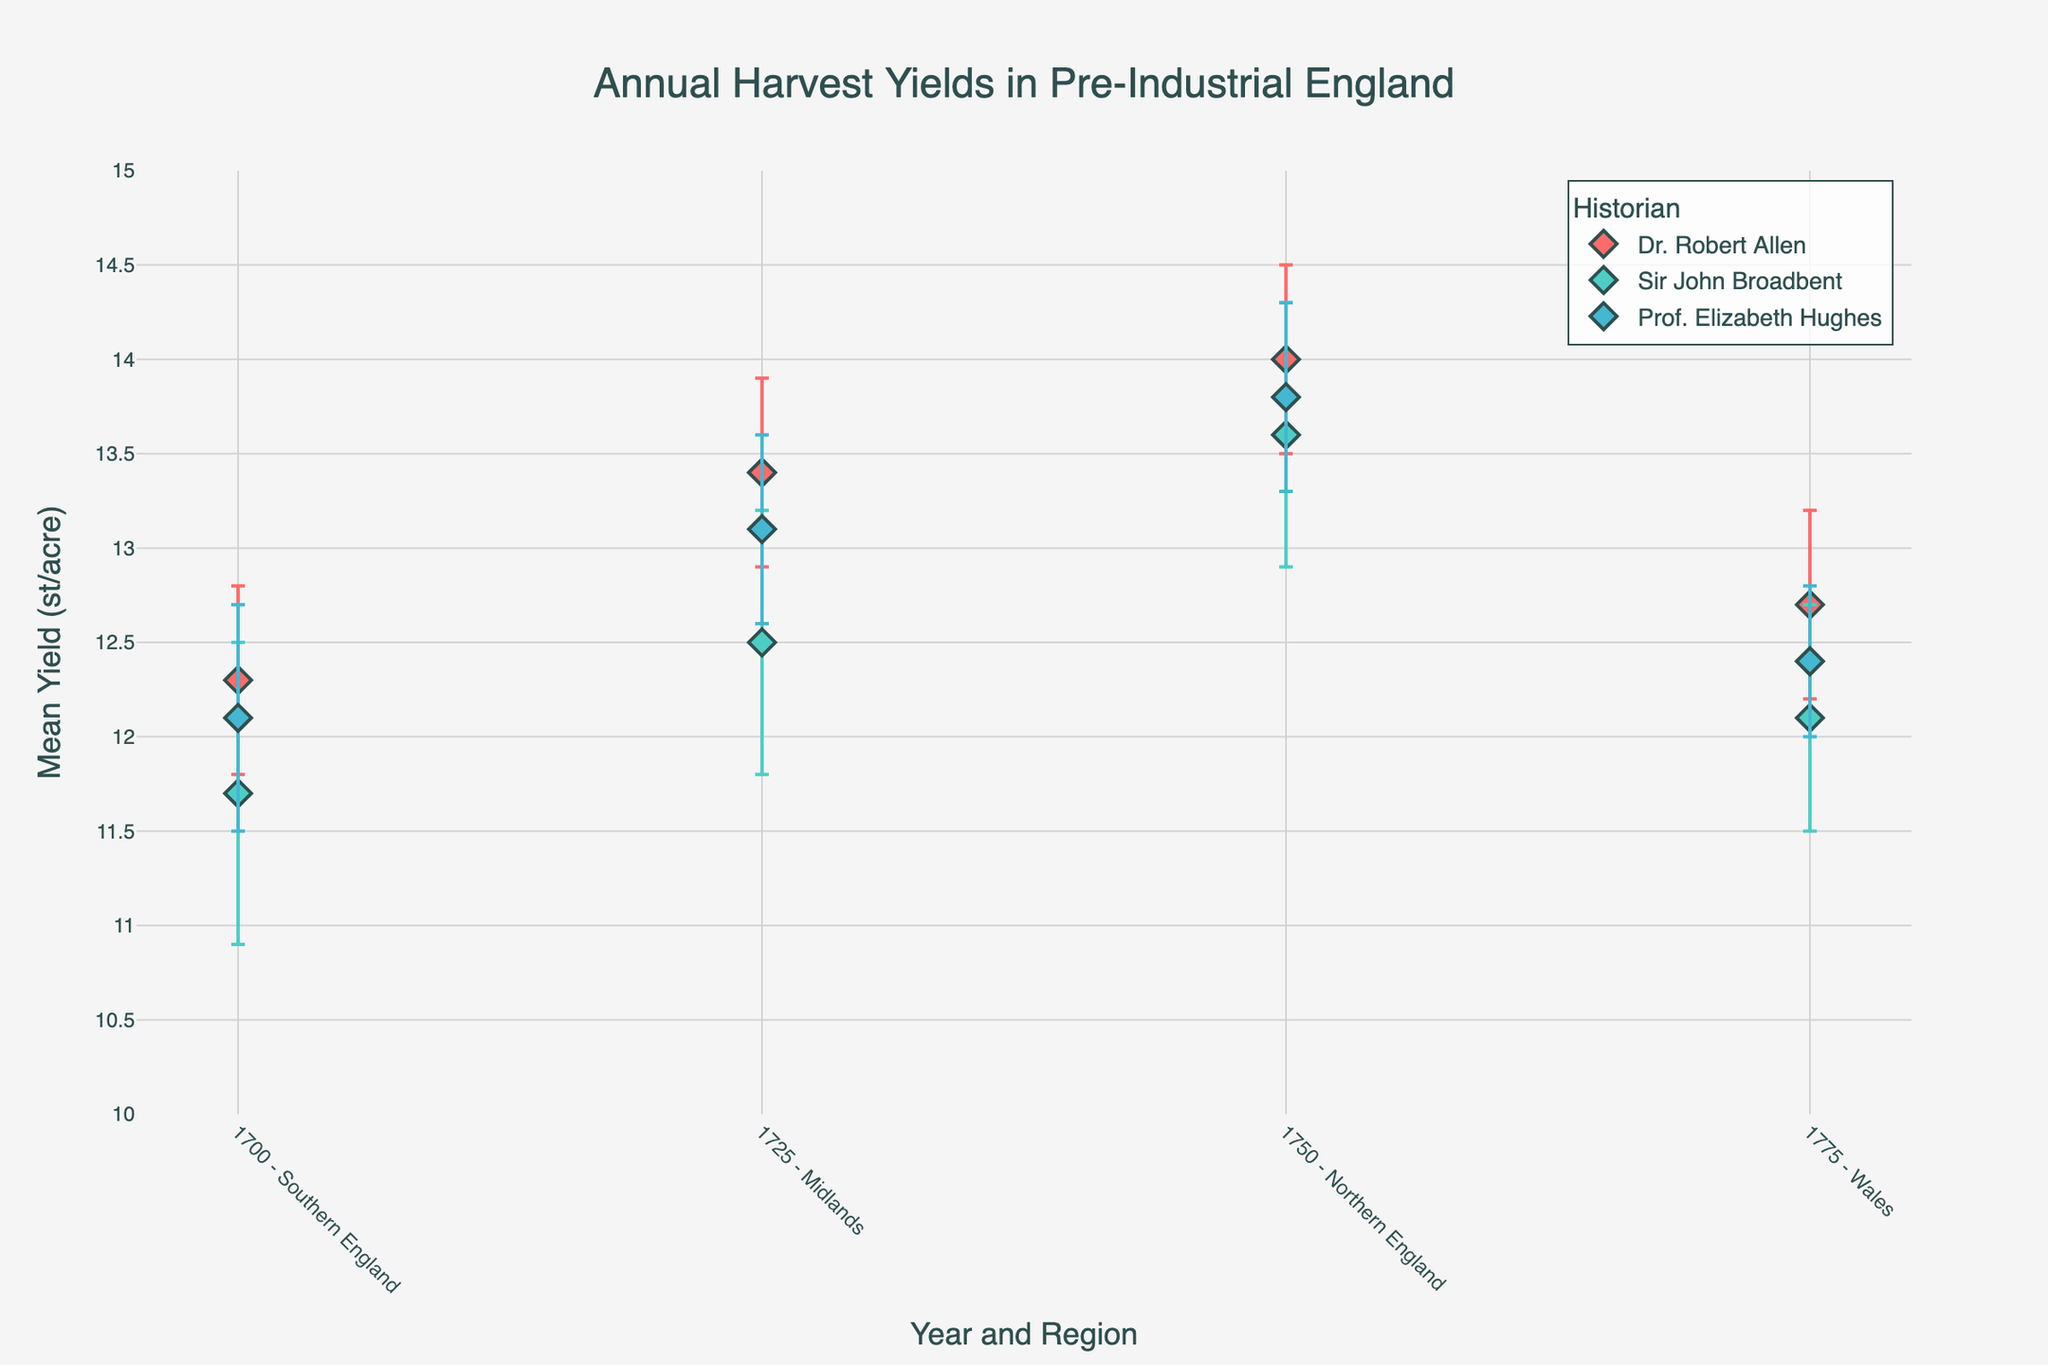what is the mean yield for Dr. Robert Allen in Southern England, 1700? The dot plot shows the mean yield for Dr. Robert Allen in Southern England, 1700, which is marked by a specific symbol. Locate the corresponding dot and read the value directly.
Answer: 12.3 Which historian reported the highest mean yield in Northern England, 1750? Identify the dots for Northern England, 1750 for each historian. Compare the mean yield values and determine the highest one.
Answer: Dr. Robert Allen How much discrepancy is there between Sir John Broadbent and Prof. Elizabeth Hughes in the Midlands, 1725? Find the mean yield values for Sir John Broadbent and Prof. Elizabeth Hughes in the Midlands, 1725. Subtract the former from the latter.
Answer: 0.6 What's the average of the mean yields for all historians in Wales in 1775? Sum the mean yields for Dr. Robert Allen, Sir John Broadbent, and Prof. Elizabeth Hughes in Wales, 1775, and then divide by 3 to get the average.
Answer: 12.4 Compare the widest confidence interval in Southern England, 1700 among the historians. Which historian has it? Calculate the range (Upper CI - Lower CI) for each historian in Southern England, 1700. The historian with the highest range has the widest confidence interval.
Answer: Sir John Broadbent Which region in the graph shows the least discrepancy among the historians' mean yields? For each region/year pair, calculate the discrepancy as the difference between the highest and the lowest mean yield among the historians. The region with the smallest discrepancy is the answer.
Answer: Wales, 1775 Determine the historian with the lowest reported mean yield overall and state the value. Compare the reported mean yields across all historians and years. Identify the minimum value and the historian associated with it.
Answer: Sir John Broadbent, 11.7 st/acre For which year and region did Prof. Elizabeth Hughes report the highest mean yield? Look at Prof. Elizabeth Hughes' reported yields across different years and regions. Identify the highest mean yield and state the corresponding year and region.
Answer: Northern England, 1750, 13.8 st/acre 